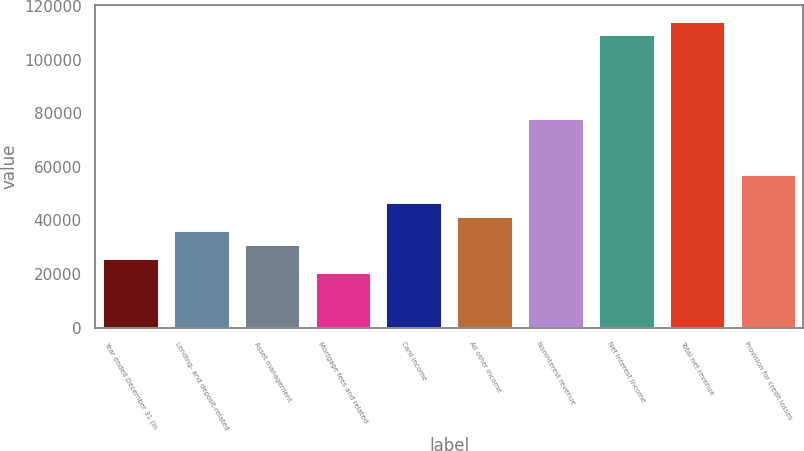Convert chart. <chart><loc_0><loc_0><loc_500><loc_500><bar_chart><fcel>Year ended December 31 (in<fcel>Lending- and deposit-related<fcel>Asset management<fcel>Mortgage fees and related<fcel>Card income<fcel>All other income<fcel>Noninterest revenue<fcel>Net interest income<fcel>Total net revenue<fcel>Provision for credit losses<nl><fcel>26053.5<fcel>36463.7<fcel>31258.6<fcel>20848.4<fcel>46873.9<fcel>41668.8<fcel>78104.5<fcel>109335<fcel>114540<fcel>57284.1<nl></chart> 